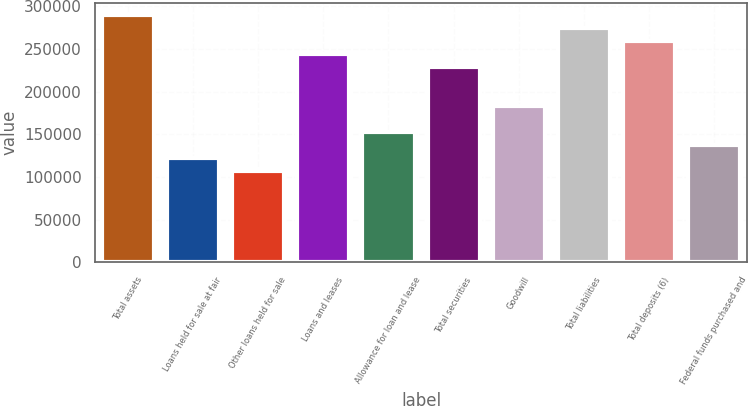Convert chart to OTSL. <chart><loc_0><loc_0><loc_500><loc_500><bar_chart><fcel>Total assets<fcel>Loans held for sale at fair<fcel>Other loans held for sale<fcel>Loans and leases<fcel>Allowance for loan and lease<fcel>Total securities<fcel>Goodwill<fcel>Total liabilities<fcel>Total deposits (6)<fcel>Federal funds purchased and<nl><fcel>289438<fcel>121869<fcel>106635<fcel>243737<fcel>152336<fcel>228504<fcel>182803<fcel>274204<fcel>258971<fcel>137102<nl></chart> 